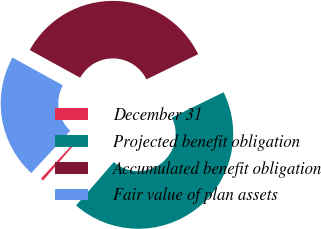<chart> <loc_0><loc_0><loc_500><loc_500><pie_chart><fcel>December 31<fcel>Projected benefit obligation<fcel>Accumulated benefit obligation<fcel>Fair value of plan assets<nl><fcel>0.47%<fcel>43.61%<fcel>34.77%<fcel>21.15%<nl></chart> 